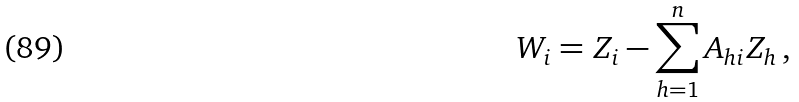<formula> <loc_0><loc_0><loc_500><loc_500>W _ { i } = Z _ { i } - \sum _ { h = 1 } ^ { n } A _ { h i } Z _ { h } \, ,</formula> 